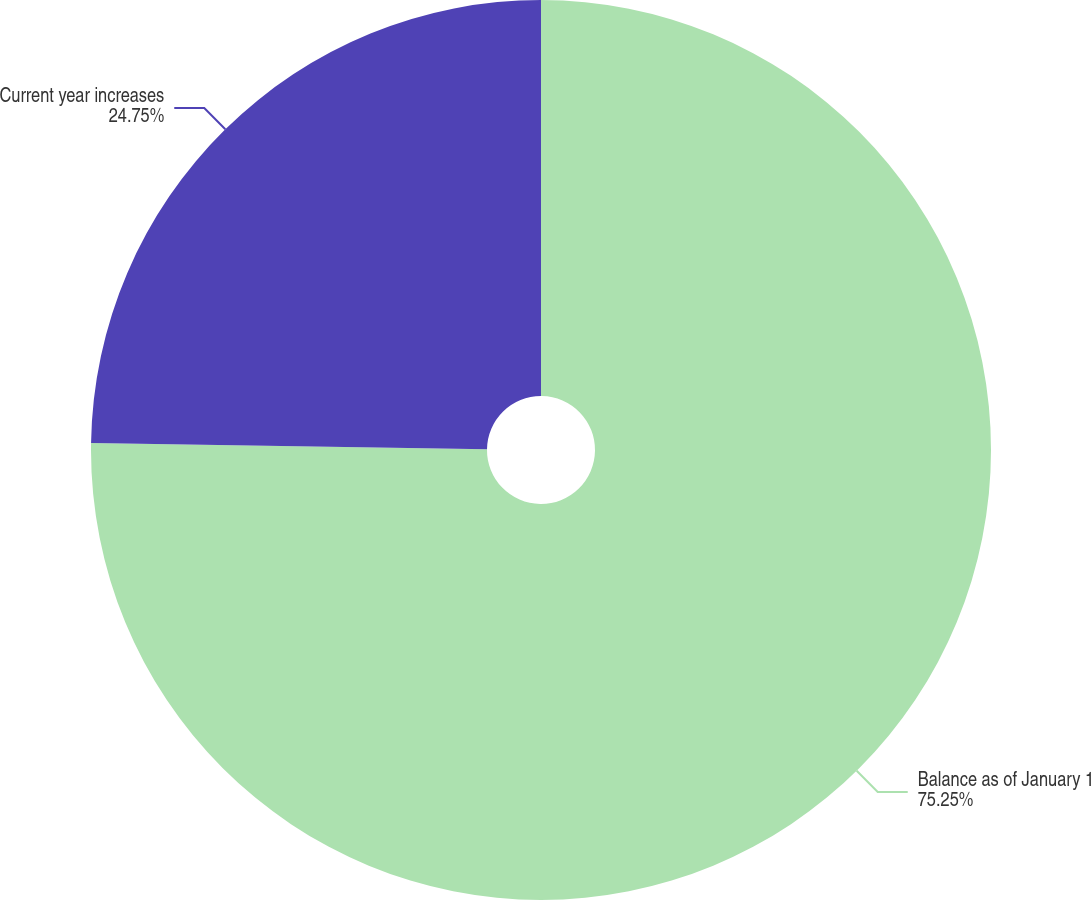Convert chart to OTSL. <chart><loc_0><loc_0><loc_500><loc_500><pie_chart><fcel>Balance as of January 1<fcel>Current year increases<nl><fcel>75.25%<fcel>24.75%<nl></chart> 